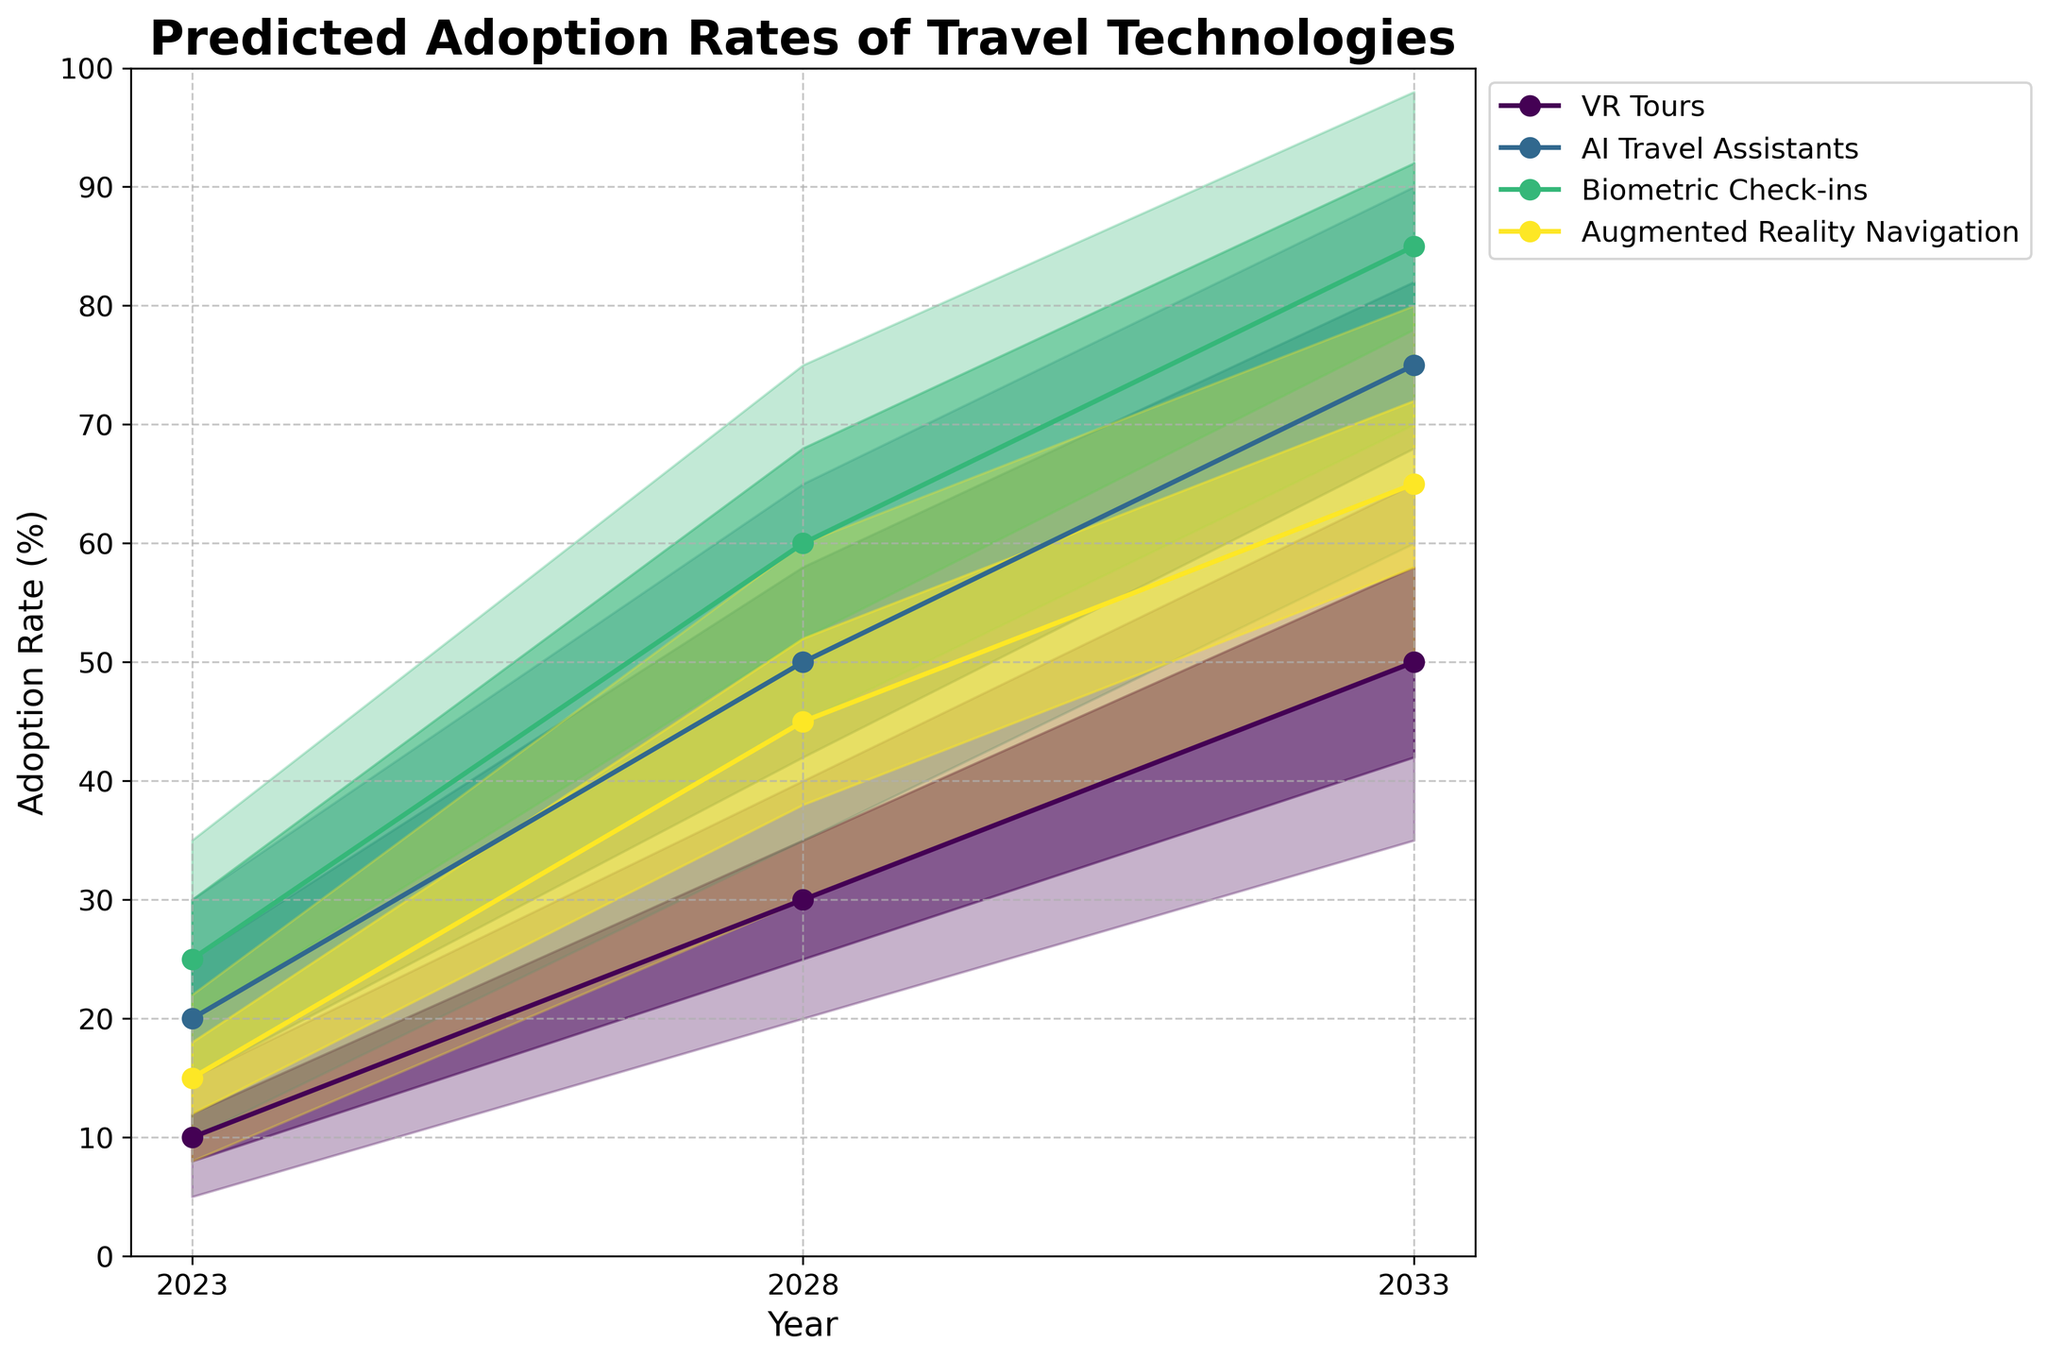How many technologies are shown in the chart? The chart depicts the adoption rates of different travel technologies over the next decade. We can identify the number of technologies by counting the distinct colors and the corresponding labels in the legend.
Answer: 4 What is the adoption rate range for AI Travel Assistants in 2028? By observing the shaded areas associated with AI Travel Assistants in 2028, we can find the lower and upper bounds, which are displayed on the y-axis.
Answer: 35% to 65% Which technology is predicted to have the highest adoption rate by 2033? By comparing the topmost lines of each technology's shaded areas or mid estimates in 2033, we can find the technology with the highest adoption rate. The highest line represents Biometric Check-ins.
Answer: Biometric Check-ins Which year shows the steepest increase in adoption rates for VR Tours? To determine the steepest increase, we need to examine the slopes of the lines representing VR Tours' mid estimates. The line between 2023 and 2028 for VR Tours has the steepest slope among the given years.
Answer: Between 2023 and 2028 Which technology has the closest mid-estimate adoption rates in 2028 and 2033? We need to check the mid-estimate lines for each technology and compare the values in 2028 and 2033. VR Tours has mid-estimate adoption rates of 30% in 2028 and 50% in 2033, which is the smallest relative change compared to the others.
Answer: VR Tours Rank the technologies by their predicted high estimates in 2028. We need to look at the predicted high estimate lines in 2028 and compare the values of the different technologies, then sort them in descending order: Biometric Check-ins (75%), AI Travel Assistants (65%), Augmented Reality Navigation (60%), VR Tours (40%).
Answer: Biometric Check-ins, AI Travel Assistants, Augmented Reality Navigation, VR Tours Which technology shows the largest spread between its low and high estimates in 2033? To determine this, calculate the difference between the high and low estimates for each technology in 2033. Biometric Check-ins has the largest spread with a range of 28% to 98%, resulting in a spread of 70%.
Answer: Biometric Check-ins What is the mid-estimate adoption rate of Augmented Reality Navigation in 2023, and how much is it predicted to increase by 2033? Check the mid-estimate line at 2023 and compare it to 2033 for Augmented Reality Navigation. The mid-estimate adoption rate in 2023 is 15%, and in 2033 it is 65%. The increase is calculated as 65% - 15% = 50%.
Answer: 15%, 50% increase 